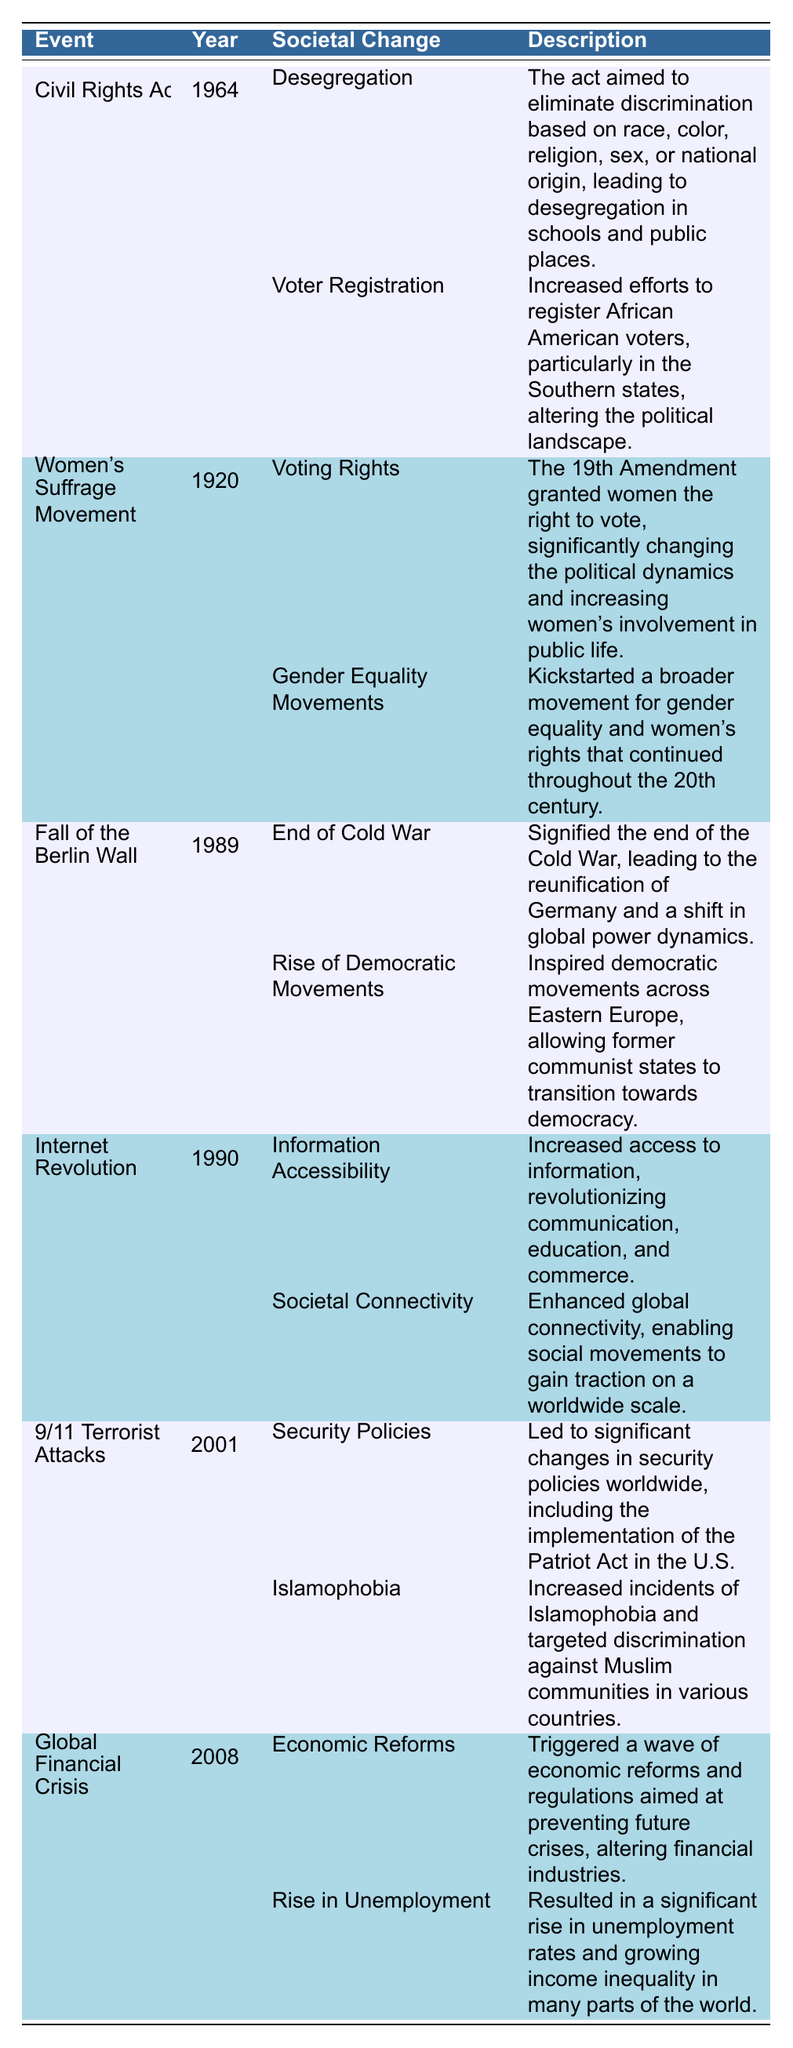What year did the Civil Rights Act occur? The table lists the Civil Rights Act under the "Event" column and shows "1964" in the "Year" column corresponding to it.
Answer: 1964 What societal change was initiated by the Women's Suffrage Movement? The table indicates that one of the impacts listed under the Women's Suffrage Movement is "Voting Rights."
Answer: Voting Rights Did the Fall of the Berlin Wall mark the end of the Cold War? The table states that the end of the Cold War is one of the societal changes resulting from the Fall of the Berlin Wall.
Answer: Yes What are two impacts of the Internet Revolution? The table shows two societal changes listed under the Internet Revolution: "Information Accessibility" and "Societal Connectivity."
Answer: Information Accessibility and Societal Connectivity Which event occurred first, the Global Financial Crisis or the Civil Rights Act? The table displays the Civil Rights Act as occurring in 1964 and the Global Financial Crisis in 2008. Therefore, the Civil Rights Act occurred before the Global Financial Crisis.
Answer: Civil Rights Act How many societal changes resulted from the 9/11 Terrorist Attacks? According to the table, there are two societal changes listed under the 9/11 Terrorist Attacks: "Security Policies" and "Islamophobia."
Answer: Two Was increased voter registration a result of the Civil Rights Act? The table indicates that "Increased efforts to register African American voters" is listed as an impact of the Civil Rights Act, confirming that it was a result.
Answer: Yes How do the years of the Internet Revolution and the Fall of the Berlin Wall compare? The Internet Revolution took place in 1990 and the Fall of the Berlin Wall in 1989. Since 1990 is later than 1989, the Internet Revolution occurred after the Fall of the Berlin Wall.
Answer: Internet Revolution occurred later What societal change resulted from the Global Financial Crisis regarding unemployment? The table shows "Rise in Unemployment" as one of the impacts of the Global Financial Crisis.
Answer: Rise in Unemployment Which event led to a significant increase in Islamophobia? The 9/11 Terrorist Attacks led to an increase in Islamophobia, as stated in the table.
Answer: 9/11 Terrorist Attacks What societal change related to democracy was inspired by the Fall of the Berlin Wall? The table indicates that the Fall of the Berlin Wall inspired "Rise of Democratic Movements" across Eastern Europe.
Answer: Rise of Democratic Movements 